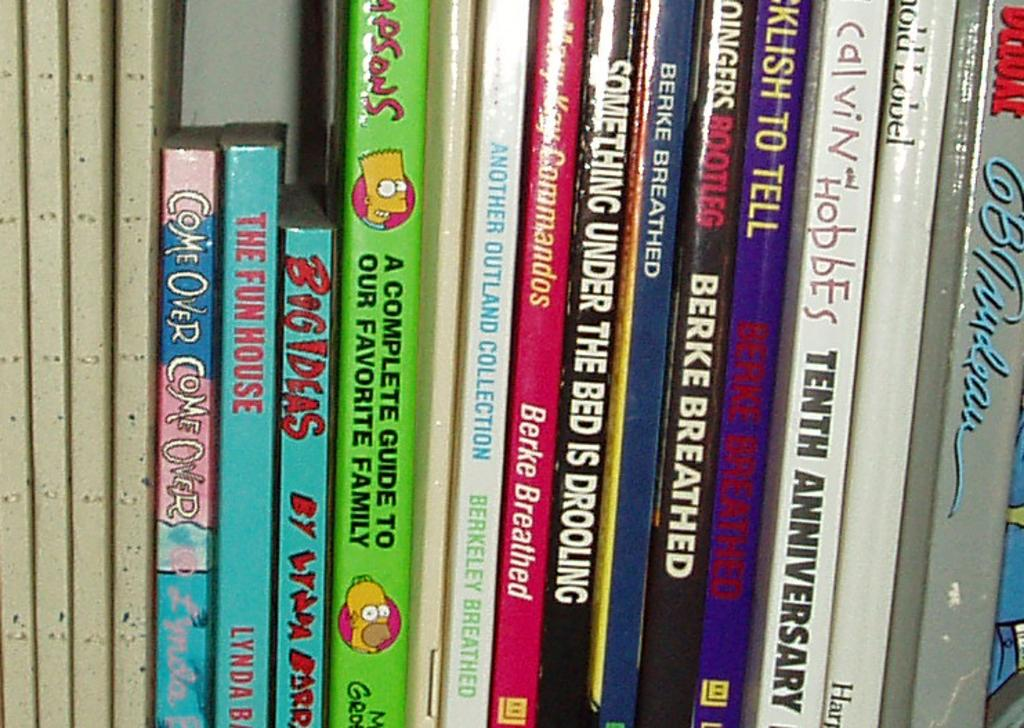What objects are present in the image? There are books in the image. How are the books arranged in the image? The books are arranged in an order. Where is the throne located in the image? There is no throne present in the image. What type of baseball equipment can be seen in the image? There is no baseball equipment present in the image. 